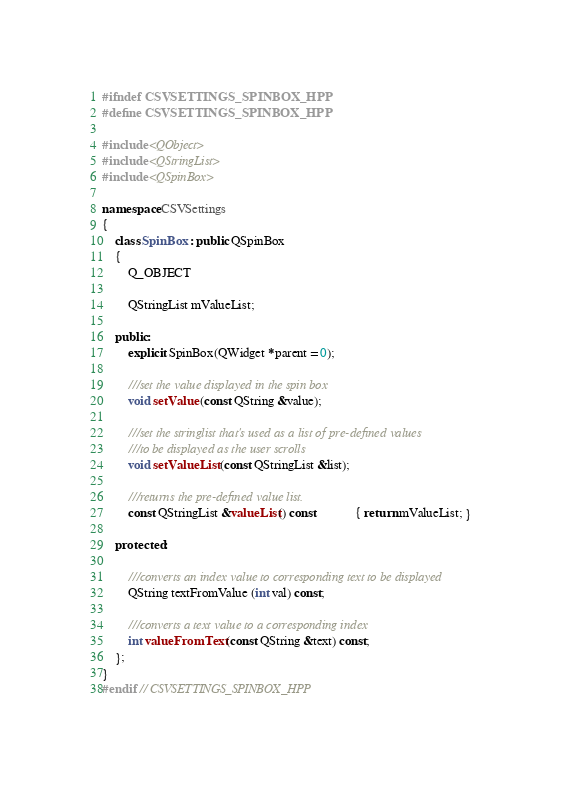<code> <loc_0><loc_0><loc_500><loc_500><_C++_>#ifndef CSVSETTINGS_SPINBOX_HPP
#define CSVSETTINGS_SPINBOX_HPP

#include <QObject>
#include <QStringList>
#include <QSpinBox>

namespace CSVSettings
{
    class SpinBox : public QSpinBox
    {
        Q_OBJECT

        QStringList mValueList;

    public:
        explicit SpinBox(QWidget *parent = 0);

        ///set the value displayed in the spin box
        void setValue (const QString &value);

        ///set the stringlist that's used as a list of pre-defined values
        ///to be displayed as the user scrolls
        void setValueList (const QStringList &list);

        ///returns the pre-defined value list.
        const QStringList &valueList() const            { return mValueList; }

    protected:

        ///converts an index value to corresponding text to be displayed
        QString textFromValue (int val) const;

        ///converts a text value to a corresponding index
        int valueFromText (const QString &text) const;
    };
}
#endif // CSVSETTINGS_SPINBOX_HPP
</code> 